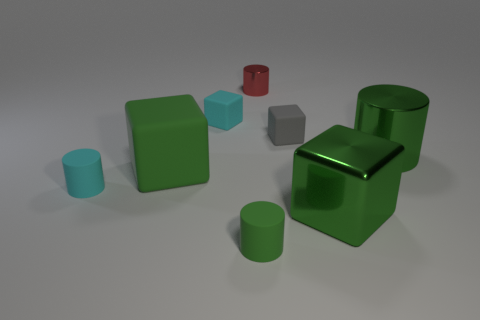Subtract 1 cubes. How many cubes are left? 3 Add 1 tiny red metal things. How many objects exist? 9 Add 5 small metal cylinders. How many small metal cylinders exist? 6 Subtract 0 purple blocks. How many objects are left? 8 Subtract all purple matte cylinders. Subtract all small blocks. How many objects are left? 6 Add 1 large green objects. How many large green objects are left? 4 